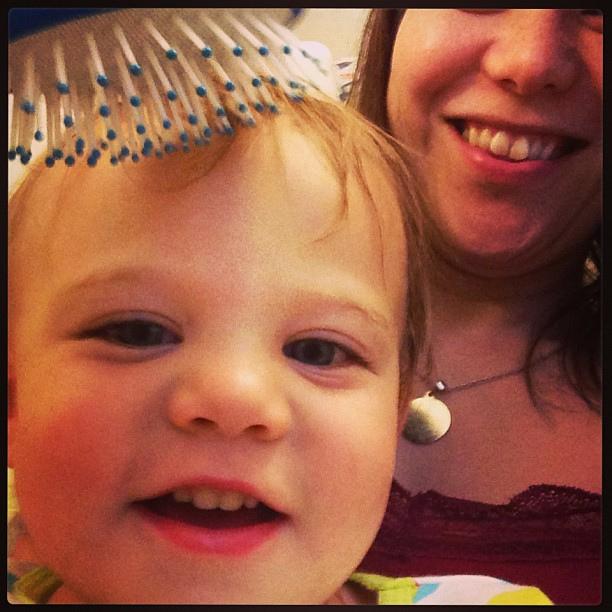Is there a hair brush in this picture?
Short answer required. Yes. Is the people in front of the woman?
Be succinct. Yes. Is the child being held?
Be succinct. Yes. Is the kid happy?
Give a very brief answer. Yes. Is the boy on the left standing in a shopping cart?
Concise answer only. No. What is the gender of this child?
Write a very short answer. Female. 